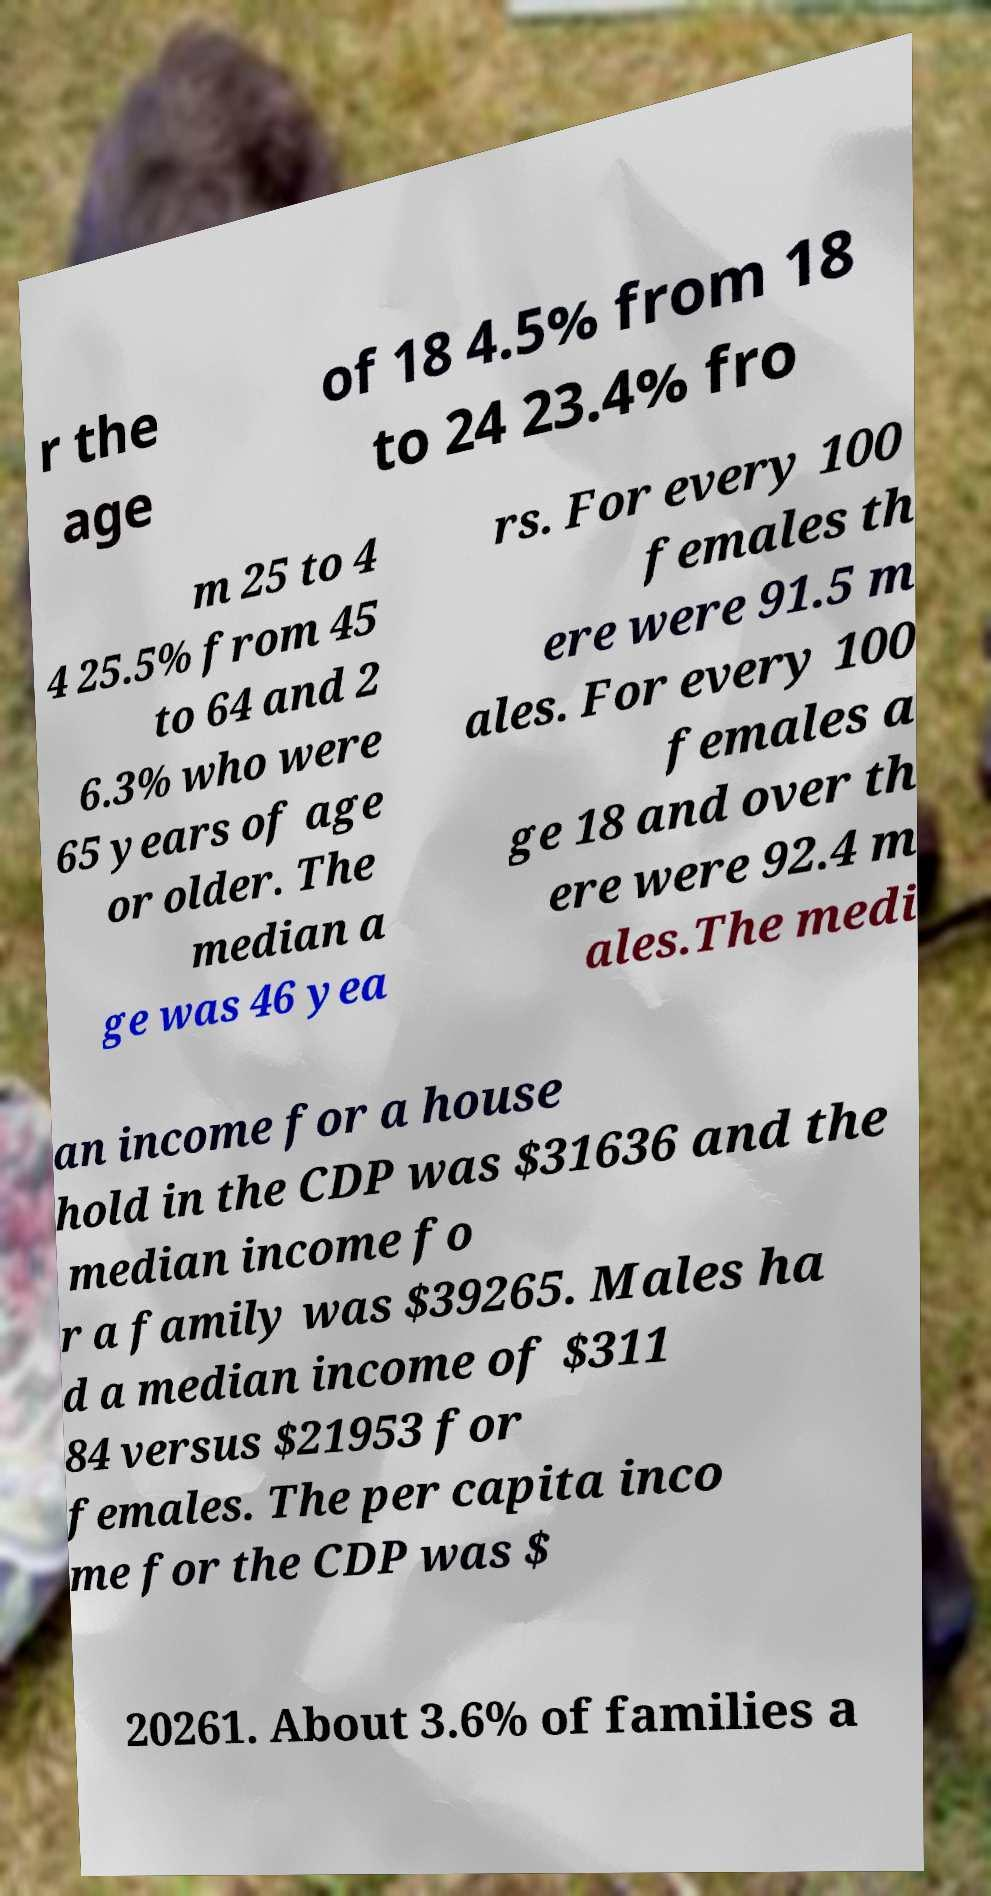For documentation purposes, I need the text within this image transcribed. Could you provide that? r the age of 18 4.5% from 18 to 24 23.4% fro m 25 to 4 4 25.5% from 45 to 64 and 2 6.3% who were 65 years of age or older. The median a ge was 46 yea rs. For every 100 females th ere were 91.5 m ales. For every 100 females a ge 18 and over th ere were 92.4 m ales.The medi an income for a house hold in the CDP was $31636 and the median income fo r a family was $39265. Males ha d a median income of $311 84 versus $21953 for females. The per capita inco me for the CDP was $ 20261. About 3.6% of families a 